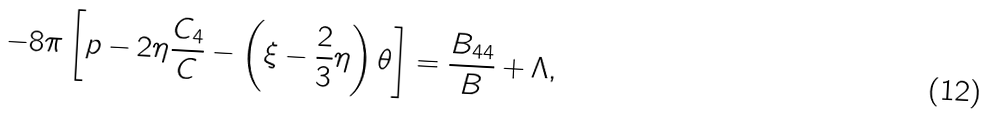Convert formula to latex. <formula><loc_0><loc_0><loc_500><loc_500>- 8 \pi \left [ p - 2 \eta \frac { C _ { 4 } } { C } - \left ( \xi - \frac { 2 } { 3 } \eta \right ) \theta \right ] = \frac { B _ { 4 4 } } { B } + \Lambda ,</formula> 